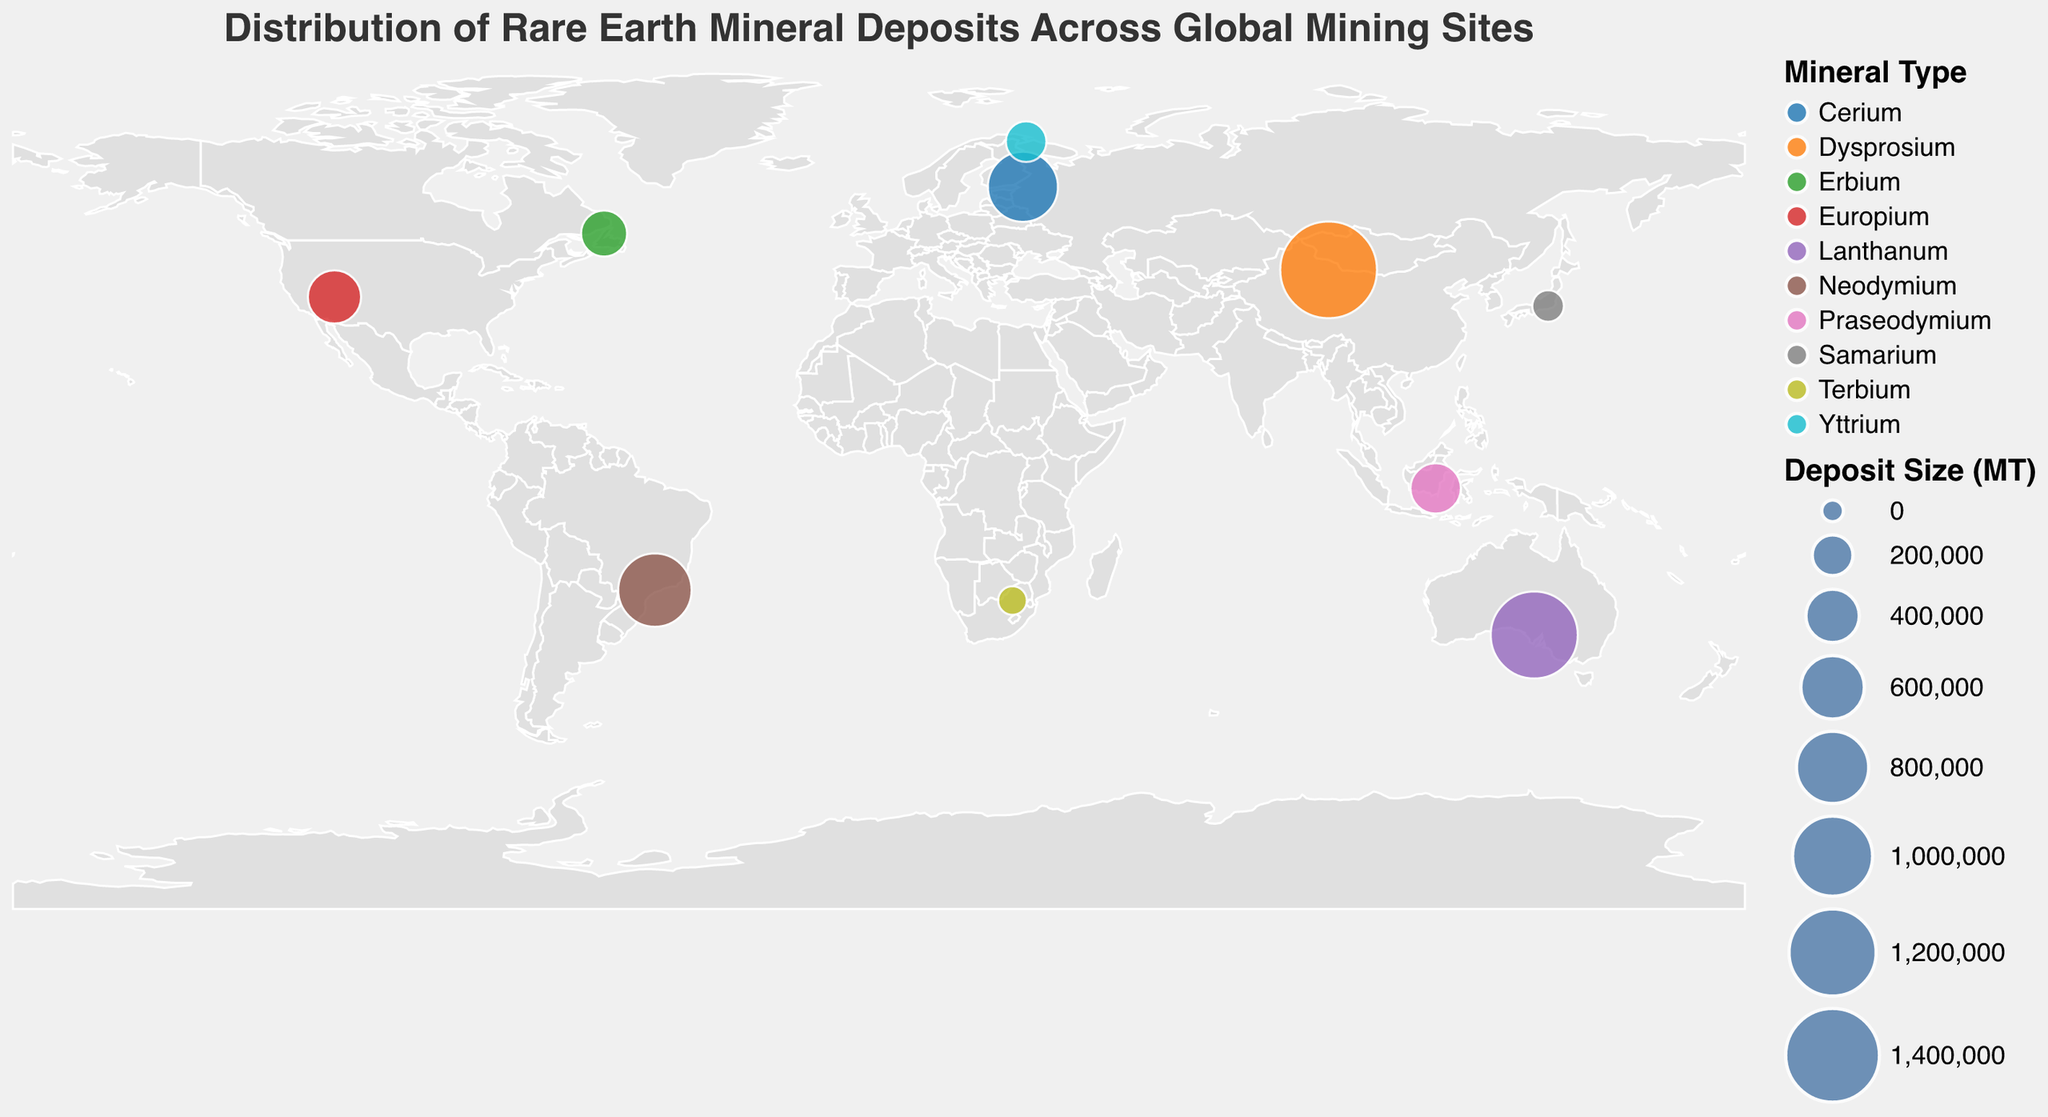What's the title of the figure? The title of the figure is displayed at the top and provides a summary of what the figure represents.
Answer: Distribution of Rare Earth Mineral Deposits Across Global Mining Sites Which country has the largest rare earth mineral deposit according to the figure? By referring to the data points and the size of the circles, the largest deposit size appears to be in China at the Bayan Obo site.
Answer: China How many mining sites are displayed on the figure? By counting the number of data points (circles) on the figure, you can determine the number of mining sites shown.
Answer: 10 What is the smallest deposit size shown, and which site does it belong to? To answer this, look for the smallest circle on the map and then reference the tooltip information for the deposit size and site name. The smallest circle corresponds to Steenkampskraal with a deposit size of 60,000 MT.
Answer: Steenkampskraal, 60,000 MT Compare the deposit sizes of Mount Weld and Mountain Pass. Which one is larger, and by how much? Identify the locations of Mount Weld and Mountain Pass, check their deposit sizes, and calculate the difference: Mount Weld (1,200,000 MT) - Mountain Pass (400,000 MT) = 800,000 MT.
Answer: Mount Weld is larger by 800,000 MT What mineral type is found at the Tantalus site? Refer to the data point for Tantalus on the map, and check the color and tool-tip information to identify the mineral type.
Answer: Praseodymium Among the displayed sites, which has the highest concentration of Yttrium? Look for the circles representing Yttrium and compare their sizes. Norra Kärr in Sweden shows the largest deposit size for Yttrium.
Answer: Norra Kärr, Sweden What is the total rare earth mineral deposit size for all the sites located in the southern hemisphere? Sum the deposit sizes for the sites in the southern hemisphere: Serra Verde (830,000 MT), Mount Weld (1,200,000 MT), Steenkampskraal (60,000 MT), Tantalus (350,000 MT). Total = 830,000 + 1,200,000 + 60,000 + 350,000 = 2,440,000 MT.
Answer: 2,440,000 MT Which country in the Americas has rare earth mineral deposits according to the figure, and what is the site called? From the map, identify the sites located in the Americas and refer to their tool-tip details. The relevant site is Mountain Pass in the USA.
Answer: USA, Mountain Pass 